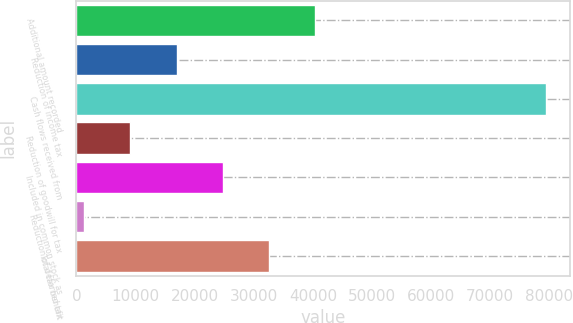<chart> <loc_0><loc_0><loc_500><loc_500><bar_chart><fcel>Additional amount recorded<fcel>Reduction of income tax<fcel>Cash flows received from<fcel>Reduction of goodwill for tax<fcel>Included in common stock as<fcel>Reduction of deferred tax<fcel>Total tax benefit<nl><fcel>40417<fcel>16960.6<fcel>79511<fcel>9141.8<fcel>24779.4<fcel>1323<fcel>32598.2<nl></chart> 